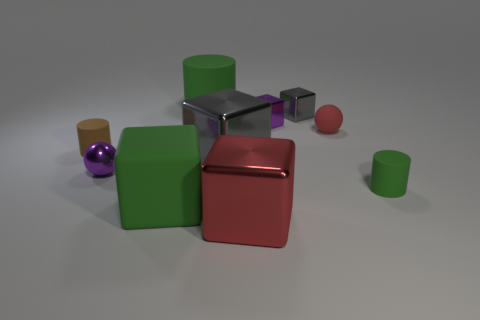There is a thing that is the same color as the rubber sphere; what is its material?
Provide a succinct answer. Metal. Is the color of the tiny matte sphere the same as the matte block?
Your answer should be very brief. No. Are there fewer green cylinders than large green rubber cubes?
Keep it short and to the point. No. There is a small green thing in front of the small metal ball; what is it made of?
Make the answer very short. Rubber. What is the material of the green thing that is the same size as the green cube?
Provide a short and direct response. Rubber. What material is the small sphere on the right side of the green rubber object that is left of the large rubber cylinder right of the brown rubber cylinder?
Make the answer very short. Rubber. There is a purple object on the right side of the purple sphere; is it the same size as the green block?
Your answer should be compact. No. Are there more brown matte objects than large gray matte balls?
Your answer should be very brief. Yes. What number of small things are either red cubes or cyan things?
Your answer should be very brief. 0. What number of other things are there of the same color as the small rubber sphere?
Offer a terse response. 1. 